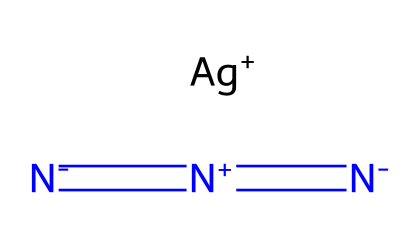What is the oxidation state of silver in silver azide? In the structure of silver azide, silver (Ag) is depicted with a positive charge (Ag+). This indicates that silver has lost one electron, giving it an oxidation state of +1.
Answer: +1 How many nitrogen atoms are present in silver azide? The provided SMILES representation shows three nitrogen atoms (N), which can be counted directly from the visual representation of the chemical structure.
Answer: 3 What type of bonds are present between the nitrogen atoms in silver azide? The SMILES notation reveals that nitrogen atoms are connected with double bonds (indicated by '='), which suggests that these nitrogen atoms are involved in multiple bond interactions with each other.
Answer: double bonds What physical property makes silver azide shock-sensitive? Silver azide is categorized as a high-energy compound, and its structure, particularly the presence of the azide group, contributes to its sensitivity to shock due to weak bonds and potential instability when disturbed.
Answer: instability What functional group characterizes azides like silver azide? The defining functional group in azides is the -N3 (azide) group, which contains three nitrogen atoms in a linear arrangement bonding with the carbon or metal, characterizing all azide compounds.
Answer: -N3 group How does the presence of silver affect the reactivity of azides? Silver ions can stabilize the azide group in the compound, but they may also alter the molecule's reactivity profile, affecting how the azide will participate in reactions, especially in pyrotechnic applications.
Answer: stability and reactivity 